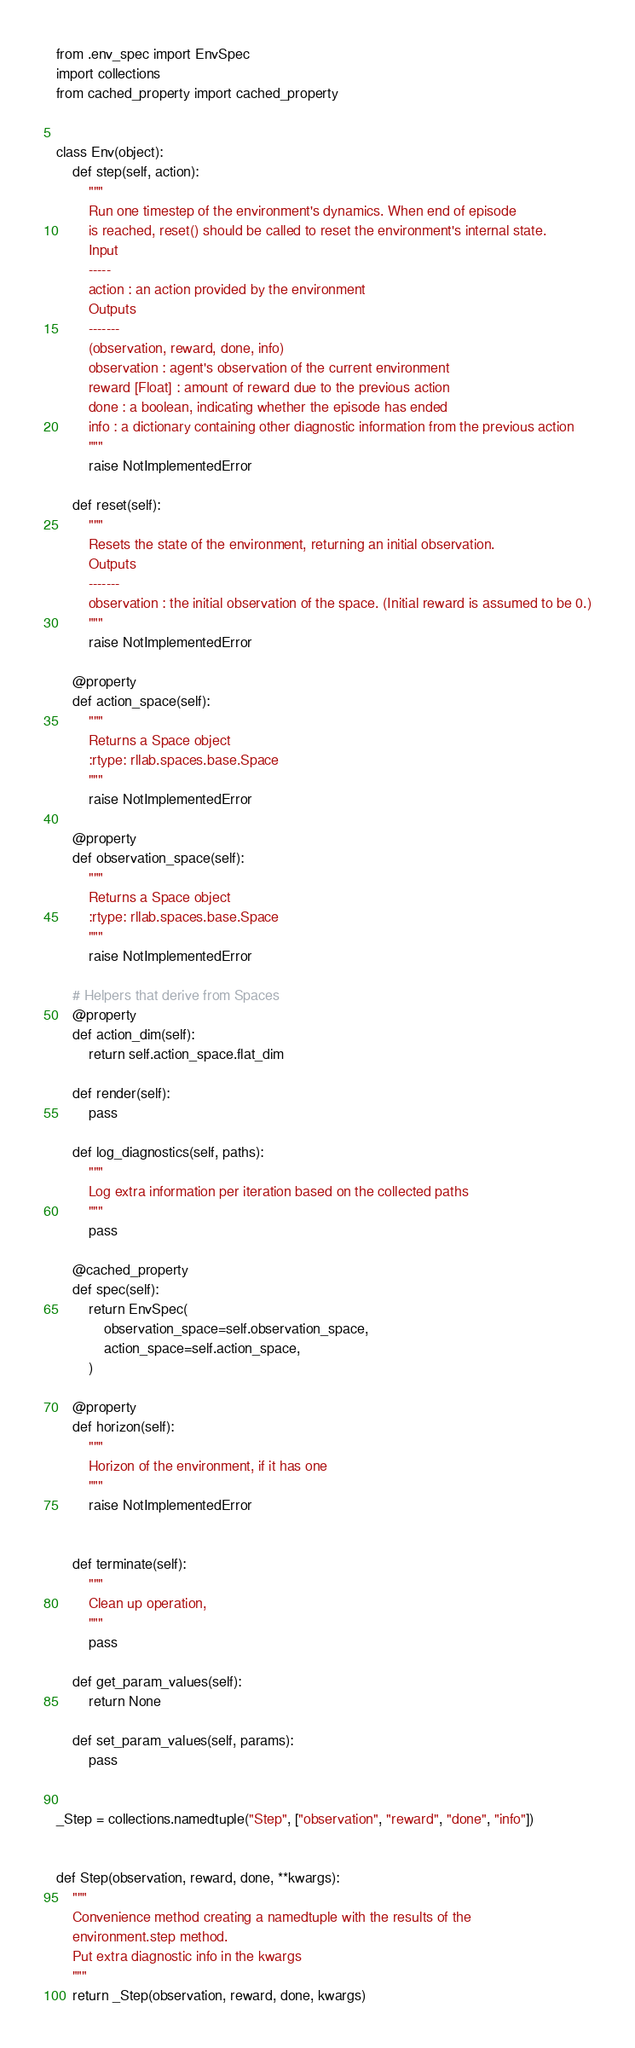<code> <loc_0><loc_0><loc_500><loc_500><_Python_>from .env_spec import EnvSpec
import collections
from cached_property import cached_property


class Env(object):
    def step(self, action):
        """
        Run one timestep of the environment's dynamics. When end of episode
        is reached, reset() should be called to reset the environment's internal state.
        Input
        -----
        action : an action provided by the environment
        Outputs
        -------
        (observation, reward, done, info)
        observation : agent's observation of the current environment
        reward [Float] : amount of reward due to the previous action
        done : a boolean, indicating whether the episode has ended
        info : a dictionary containing other diagnostic information from the previous action
        """
        raise NotImplementedError

    def reset(self):
        """
        Resets the state of the environment, returning an initial observation.
        Outputs
        -------
        observation : the initial observation of the space. (Initial reward is assumed to be 0.)
        """
        raise NotImplementedError

    @property
    def action_space(self):
        """
        Returns a Space object
        :rtype: rllab.spaces.base.Space
        """
        raise NotImplementedError

    @property
    def observation_space(self):
        """
        Returns a Space object
        :rtype: rllab.spaces.base.Space
        """
        raise NotImplementedError

    # Helpers that derive from Spaces
    @property
    def action_dim(self):
        return self.action_space.flat_dim

    def render(self):
        pass

    def log_diagnostics(self, paths):
        """
        Log extra information per iteration based on the collected paths
        """
        pass

    @cached_property
    def spec(self):
        return EnvSpec(
            observation_space=self.observation_space,
            action_space=self.action_space,
        )

    @property
    def horizon(self):
        """
        Horizon of the environment, if it has one
        """
        raise NotImplementedError


    def terminate(self):
        """
        Clean up operation,
        """
        pass

    def get_param_values(self):
        return None

    def set_param_values(self, params):
        pass


_Step = collections.namedtuple("Step", ["observation", "reward", "done", "info"])


def Step(observation, reward, done, **kwargs):
    """
    Convenience method creating a namedtuple with the results of the
    environment.step method.
    Put extra diagnostic info in the kwargs
    """
    return _Step(observation, reward, done, kwargs)
</code> 